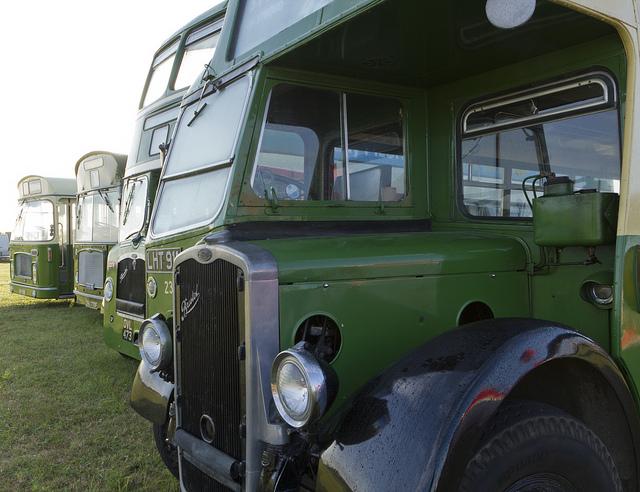What color is the truck?
Quick response, please. Green. What color are the buses?
Answer briefly. Green. How many decks does the bus in the front have?
Be succinct. 2. Is this taken outdoors?
Give a very brief answer. Yes. What color is the car?
Write a very short answer. Green. How many buses are there?
Quick response, please. 4. 